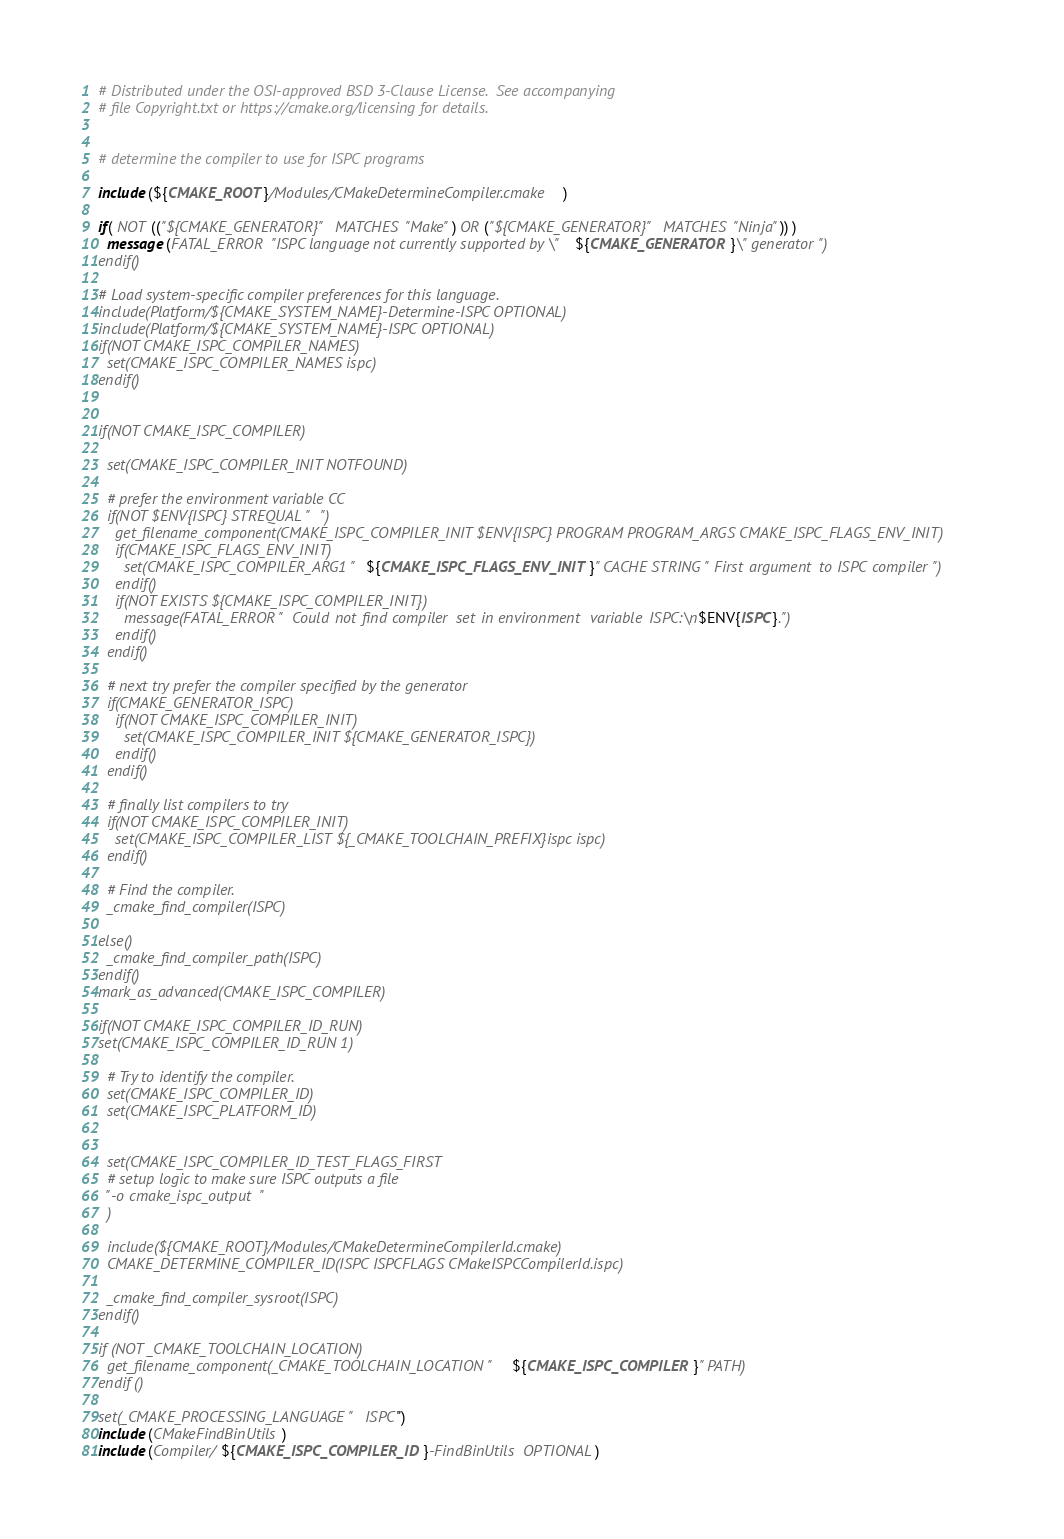<code> <loc_0><loc_0><loc_500><loc_500><_CMake_># Distributed under the OSI-approved BSD 3-Clause License.  See accompanying
# file Copyright.txt or https://cmake.org/licensing for details.


# determine the compiler to use for ISPC programs

include(${CMAKE_ROOT}/Modules/CMakeDetermineCompiler.cmake)

if( NOT (("${CMAKE_GENERATOR}" MATCHES "Make") OR ("${CMAKE_GENERATOR}" MATCHES "Ninja")) )
  message(FATAL_ERROR "ISPC language not currently supported by \"${CMAKE_GENERATOR}\" generator")
endif()

# Load system-specific compiler preferences for this language.
include(Platform/${CMAKE_SYSTEM_NAME}-Determine-ISPC OPTIONAL)
include(Platform/${CMAKE_SYSTEM_NAME}-ISPC OPTIONAL)
if(NOT CMAKE_ISPC_COMPILER_NAMES)
  set(CMAKE_ISPC_COMPILER_NAMES ispc)
endif()


if(NOT CMAKE_ISPC_COMPILER)

  set(CMAKE_ISPC_COMPILER_INIT NOTFOUND)

  # prefer the environment variable CC
  if(NOT $ENV{ISPC} STREQUAL "")
    get_filename_component(CMAKE_ISPC_COMPILER_INIT $ENV{ISPC} PROGRAM PROGRAM_ARGS CMAKE_ISPC_FLAGS_ENV_INIT)
    if(CMAKE_ISPC_FLAGS_ENV_INIT)
      set(CMAKE_ISPC_COMPILER_ARG1 "${CMAKE_ISPC_FLAGS_ENV_INIT}" CACHE STRING "First argument to ISPC compiler")
    endif()
    if(NOT EXISTS ${CMAKE_ISPC_COMPILER_INIT})
      message(FATAL_ERROR "Could not find compiler set in environment variable ISPC:\n$ENV{ISPC}.")
    endif()
  endif()

  # next try prefer the compiler specified by the generator
  if(CMAKE_GENERATOR_ISPC)
    if(NOT CMAKE_ISPC_COMPILER_INIT)
      set(CMAKE_ISPC_COMPILER_INIT ${CMAKE_GENERATOR_ISPC})
    endif()
  endif()

  # finally list compilers to try
  if(NOT CMAKE_ISPC_COMPILER_INIT)
    set(CMAKE_ISPC_COMPILER_LIST ${_CMAKE_TOOLCHAIN_PREFIX}ispc ispc)
  endif()

  # Find the compiler.
  _cmake_find_compiler(ISPC)

else()
  _cmake_find_compiler_path(ISPC)
endif()
mark_as_advanced(CMAKE_ISPC_COMPILER)

if(NOT CMAKE_ISPC_COMPILER_ID_RUN)
set(CMAKE_ISPC_COMPILER_ID_RUN 1)

  # Try to identify the compiler.
  set(CMAKE_ISPC_COMPILER_ID)
  set(CMAKE_ISPC_PLATFORM_ID)


  set(CMAKE_ISPC_COMPILER_ID_TEST_FLAGS_FIRST
  # setup logic to make sure ISPC outputs a file
  "-o cmake_ispc_output"
  )

  include(${CMAKE_ROOT}/Modules/CMakeDetermineCompilerId.cmake)
  CMAKE_DETERMINE_COMPILER_ID(ISPC ISPCFLAGS CMakeISPCCompilerId.ispc)

  _cmake_find_compiler_sysroot(ISPC)
endif()

if (NOT _CMAKE_TOOLCHAIN_LOCATION)
  get_filename_component(_CMAKE_TOOLCHAIN_LOCATION "${CMAKE_ISPC_COMPILER}" PATH)
endif ()

set(_CMAKE_PROCESSING_LANGUAGE "ISPC")
include(CMakeFindBinUtils)
include(Compiler/${CMAKE_ISPC_COMPILER_ID}-FindBinUtils OPTIONAL)</code> 